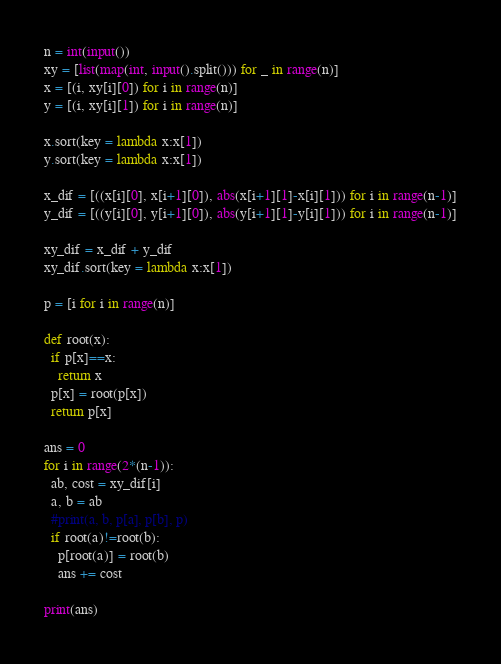Convert code to text. <code><loc_0><loc_0><loc_500><loc_500><_Python_>n = int(input())
xy = [list(map(int, input().split())) for _ in range(n)]
x = [(i, xy[i][0]) for i in range(n)]
y = [(i, xy[i][1]) for i in range(n)]

x.sort(key = lambda x:x[1])
y.sort(key = lambda x:x[1])

x_dif = [((x[i][0], x[i+1][0]), abs(x[i+1][1]-x[i][1])) for i in range(n-1)]
y_dif = [((y[i][0], y[i+1][0]), abs(y[i+1][1]-y[i][1])) for i in range(n-1)]

xy_dif = x_dif + y_dif
xy_dif.sort(key = lambda x:x[1])

p = [i for i in range(n)]

def root(x):
  if p[x]==x:
    return x
  p[x] = root(p[x])
  return p[x]

ans = 0
for i in range(2*(n-1)):
  ab, cost = xy_dif[i]
  a, b = ab
  #print(a, b, p[a], p[b], p)
  if root(a)!=root(b):
    p[root(a)] = root(b)
    ans += cost

print(ans)
</code> 